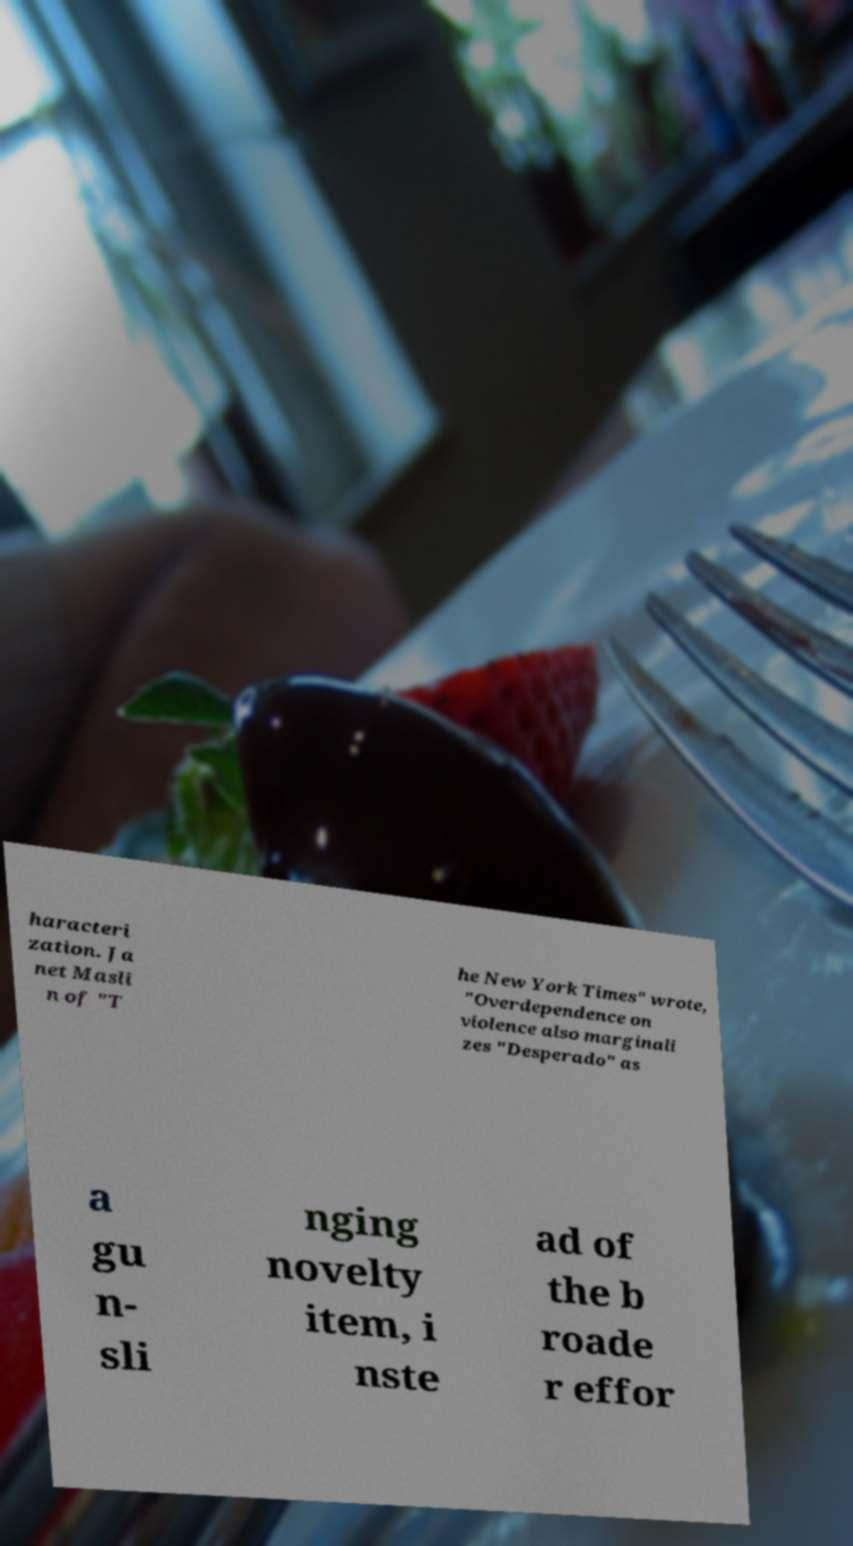For documentation purposes, I need the text within this image transcribed. Could you provide that? haracteri zation. Ja net Masli n of "T he New York Times" wrote, "Overdependence on violence also marginali zes "Desperado" as a gu n- sli nging novelty item, i nste ad of the b roade r effor 